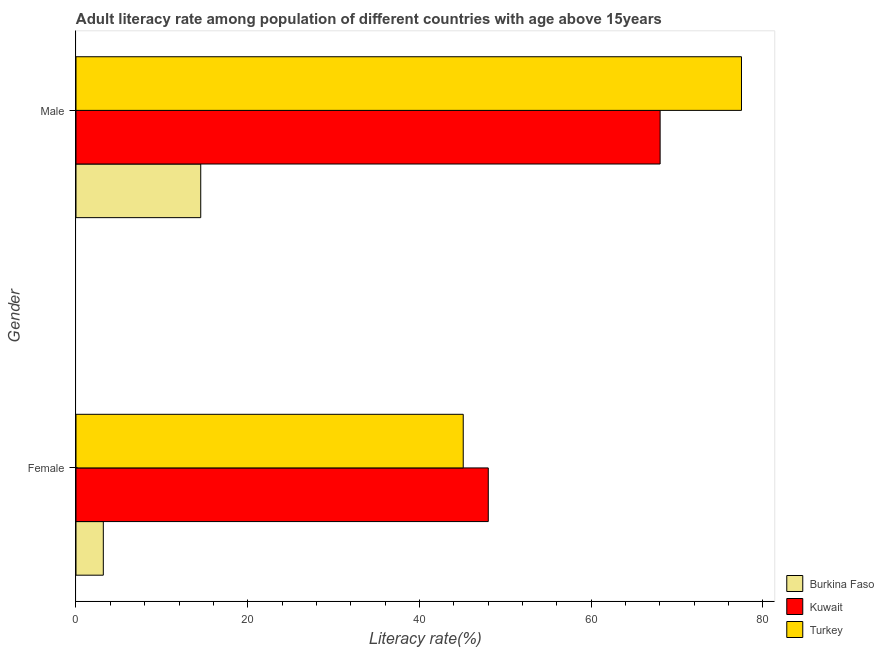Are the number of bars per tick equal to the number of legend labels?
Keep it short and to the point. Yes. What is the male adult literacy rate in Turkey?
Offer a very short reply. 77.5. Across all countries, what is the maximum male adult literacy rate?
Provide a succinct answer. 77.5. Across all countries, what is the minimum male adult literacy rate?
Make the answer very short. 14.53. In which country was the male adult literacy rate maximum?
Provide a succinct answer. Turkey. In which country was the male adult literacy rate minimum?
Provide a succinct answer. Burkina Faso. What is the total male adult literacy rate in the graph?
Ensure brevity in your answer.  160.06. What is the difference between the female adult literacy rate in Burkina Faso and that in Turkey?
Provide a succinct answer. -41.92. What is the difference between the female adult literacy rate in Turkey and the male adult literacy rate in Burkina Faso?
Provide a short and direct response. 30.57. What is the average male adult literacy rate per country?
Your answer should be compact. 53.35. What is the difference between the female adult literacy rate and male adult literacy rate in Turkey?
Offer a very short reply. -32.41. What is the ratio of the male adult literacy rate in Turkey to that in Kuwait?
Keep it short and to the point. 1.14. Is the male adult literacy rate in Kuwait less than that in Turkey?
Your response must be concise. Yes. In how many countries, is the female adult literacy rate greater than the average female adult literacy rate taken over all countries?
Your answer should be very brief. 2. What does the 2nd bar from the top in Female represents?
Keep it short and to the point. Kuwait. What does the 1st bar from the bottom in Female represents?
Your answer should be very brief. Burkina Faso. How many countries are there in the graph?
Make the answer very short. 3. Are the values on the major ticks of X-axis written in scientific E-notation?
Your answer should be very brief. No. Does the graph contain grids?
Offer a terse response. No. How are the legend labels stacked?
Offer a terse response. Vertical. What is the title of the graph?
Provide a short and direct response. Adult literacy rate among population of different countries with age above 15years. Does "San Marino" appear as one of the legend labels in the graph?
Offer a very short reply. No. What is the label or title of the X-axis?
Your answer should be very brief. Literacy rate(%). What is the Literacy rate(%) in Burkina Faso in Female?
Make the answer very short. 3.18. What is the Literacy rate(%) in Kuwait in Female?
Give a very brief answer. 48.02. What is the Literacy rate(%) in Turkey in Female?
Provide a short and direct response. 45.1. What is the Literacy rate(%) of Burkina Faso in Male?
Provide a succinct answer. 14.53. What is the Literacy rate(%) of Kuwait in Male?
Offer a very short reply. 68.03. What is the Literacy rate(%) of Turkey in Male?
Your answer should be compact. 77.5. Across all Gender, what is the maximum Literacy rate(%) of Burkina Faso?
Ensure brevity in your answer.  14.53. Across all Gender, what is the maximum Literacy rate(%) of Kuwait?
Provide a succinct answer. 68.03. Across all Gender, what is the maximum Literacy rate(%) of Turkey?
Ensure brevity in your answer.  77.5. Across all Gender, what is the minimum Literacy rate(%) in Burkina Faso?
Provide a short and direct response. 3.18. Across all Gender, what is the minimum Literacy rate(%) of Kuwait?
Your answer should be compact. 48.02. Across all Gender, what is the minimum Literacy rate(%) of Turkey?
Provide a succinct answer. 45.1. What is the total Literacy rate(%) of Burkina Faso in the graph?
Offer a very short reply. 17.71. What is the total Literacy rate(%) in Kuwait in the graph?
Offer a very short reply. 116.04. What is the total Literacy rate(%) of Turkey in the graph?
Your response must be concise. 122.6. What is the difference between the Literacy rate(%) in Burkina Faso in Female and that in Male?
Ensure brevity in your answer.  -11.35. What is the difference between the Literacy rate(%) in Kuwait in Female and that in Male?
Offer a very short reply. -20.01. What is the difference between the Literacy rate(%) of Turkey in Female and that in Male?
Give a very brief answer. -32.41. What is the difference between the Literacy rate(%) of Burkina Faso in Female and the Literacy rate(%) of Kuwait in Male?
Provide a short and direct response. -64.85. What is the difference between the Literacy rate(%) in Burkina Faso in Female and the Literacy rate(%) in Turkey in Male?
Offer a very short reply. -74.32. What is the difference between the Literacy rate(%) of Kuwait in Female and the Literacy rate(%) of Turkey in Male?
Your answer should be compact. -29.49. What is the average Literacy rate(%) of Burkina Faso per Gender?
Your answer should be very brief. 8.86. What is the average Literacy rate(%) in Kuwait per Gender?
Offer a very short reply. 58.02. What is the average Literacy rate(%) in Turkey per Gender?
Provide a short and direct response. 61.3. What is the difference between the Literacy rate(%) in Burkina Faso and Literacy rate(%) in Kuwait in Female?
Provide a succinct answer. -44.83. What is the difference between the Literacy rate(%) of Burkina Faso and Literacy rate(%) of Turkey in Female?
Offer a terse response. -41.92. What is the difference between the Literacy rate(%) in Kuwait and Literacy rate(%) in Turkey in Female?
Provide a short and direct response. 2.92. What is the difference between the Literacy rate(%) of Burkina Faso and Literacy rate(%) of Kuwait in Male?
Your answer should be compact. -53.5. What is the difference between the Literacy rate(%) of Burkina Faso and Literacy rate(%) of Turkey in Male?
Provide a succinct answer. -62.98. What is the difference between the Literacy rate(%) of Kuwait and Literacy rate(%) of Turkey in Male?
Offer a terse response. -9.48. What is the ratio of the Literacy rate(%) of Burkina Faso in Female to that in Male?
Provide a succinct answer. 0.22. What is the ratio of the Literacy rate(%) of Kuwait in Female to that in Male?
Your response must be concise. 0.71. What is the ratio of the Literacy rate(%) of Turkey in Female to that in Male?
Offer a terse response. 0.58. What is the difference between the highest and the second highest Literacy rate(%) of Burkina Faso?
Your answer should be very brief. 11.35. What is the difference between the highest and the second highest Literacy rate(%) of Kuwait?
Your answer should be compact. 20.01. What is the difference between the highest and the second highest Literacy rate(%) of Turkey?
Offer a terse response. 32.41. What is the difference between the highest and the lowest Literacy rate(%) in Burkina Faso?
Your response must be concise. 11.35. What is the difference between the highest and the lowest Literacy rate(%) in Kuwait?
Offer a terse response. 20.01. What is the difference between the highest and the lowest Literacy rate(%) in Turkey?
Make the answer very short. 32.41. 